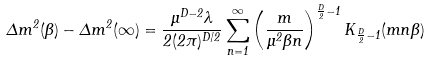Convert formula to latex. <formula><loc_0><loc_0><loc_500><loc_500>\Delta m ^ { 2 } ( \beta ) - \Delta m ^ { 2 } ( \infty ) = \frac { \mu ^ { D - 2 } \lambda } { 2 ( 2 \pi ) ^ { D / 2 } } \sum _ { n = 1 } ^ { \infty } \left ( \frac { m } { \mu ^ { 2 } \beta n } \right ) ^ { \frac { D } { 2 } - 1 } K _ { \frac { D } { 2 } - 1 } ( m n \beta )</formula> 